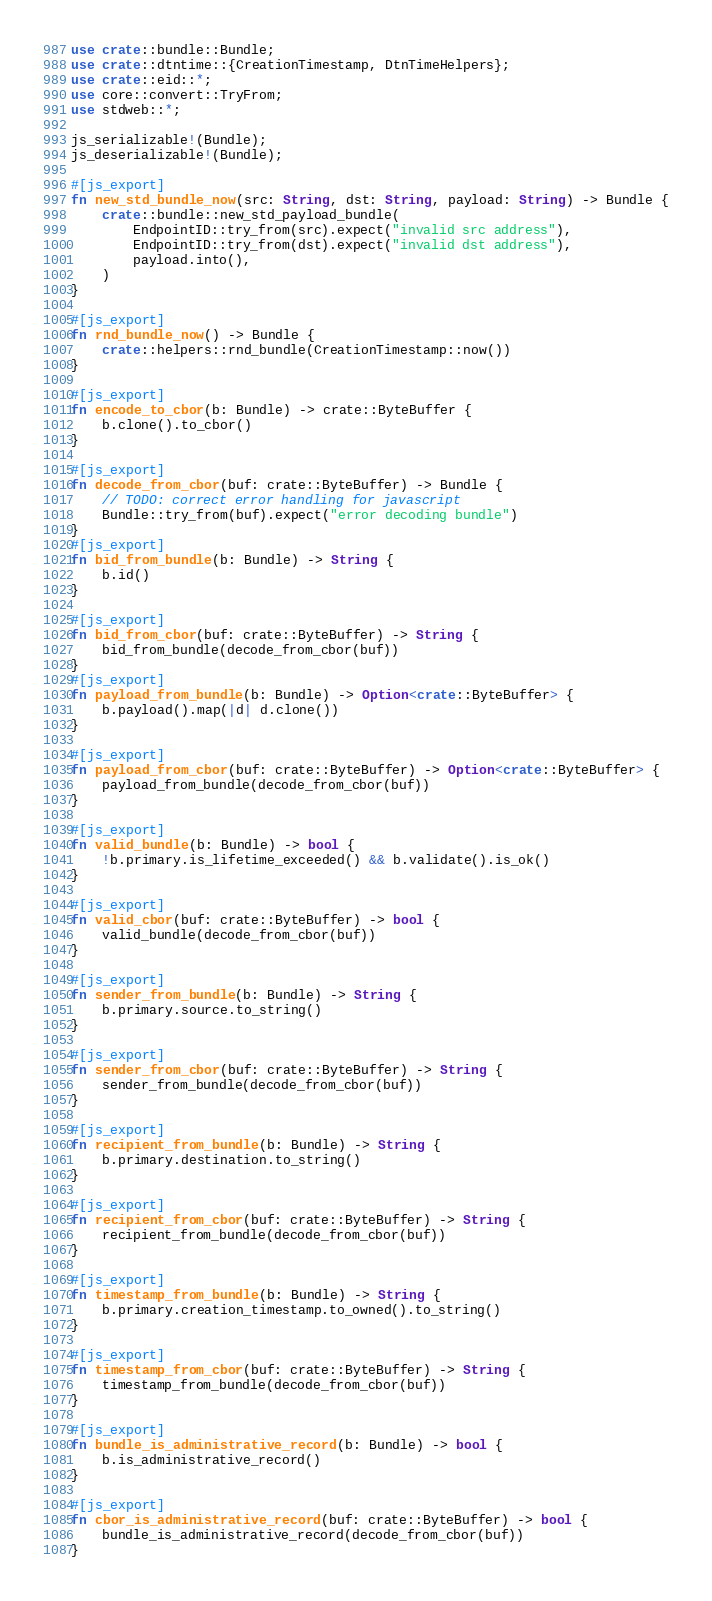<code> <loc_0><loc_0><loc_500><loc_500><_Rust_>use crate::bundle::Bundle;
use crate::dtntime::{CreationTimestamp, DtnTimeHelpers};
use crate::eid::*;
use core::convert::TryFrom;
use stdweb::*;

js_serializable!(Bundle);
js_deserializable!(Bundle);

#[js_export]
fn new_std_bundle_now(src: String, dst: String, payload: String) -> Bundle {
    crate::bundle::new_std_payload_bundle(
        EndpointID::try_from(src).expect("invalid src address"),
        EndpointID::try_from(dst).expect("invalid dst address"),
        payload.into(),
    )
}

#[js_export]
fn rnd_bundle_now() -> Bundle {
    crate::helpers::rnd_bundle(CreationTimestamp::now())
}

#[js_export]
fn encode_to_cbor(b: Bundle) -> crate::ByteBuffer {
    b.clone().to_cbor()
}

#[js_export]
fn decode_from_cbor(buf: crate::ByteBuffer) -> Bundle {
    // TODO: correct error handling for javascript
    Bundle::try_from(buf).expect("error decoding bundle")
}
#[js_export]
fn bid_from_bundle(b: Bundle) -> String {
    b.id()
}

#[js_export]
fn bid_from_cbor(buf: crate::ByteBuffer) -> String {
    bid_from_bundle(decode_from_cbor(buf))
}
#[js_export]
fn payload_from_bundle(b: Bundle) -> Option<crate::ByteBuffer> {
    b.payload().map(|d| d.clone())
}

#[js_export]
fn payload_from_cbor(buf: crate::ByteBuffer) -> Option<crate::ByteBuffer> {
    payload_from_bundle(decode_from_cbor(buf))
}

#[js_export]
fn valid_bundle(b: Bundle) -> bool {
    !b.primary.is_lifetime_exceeded() && b.validate().is_ok()
}

#[js_export]
fn valid_cbor(buf: crate::ByteBuffer) -> bool {
    valid_bundle(decode_from_cbor(buf))
}

#[js_export]
fn sender_from_bundle(b: Bundle) -> String {
    b.primary.source.to_string()
}

#[js_export]
fn sender_from_cbor(buf: crate::ByteBuffer) -> String {
    sender_from_bundle(decode_from_cbor(buf))
}

#[js_export]
fn recipient_from_bundle(b: Bundle) -> String {
    b.primary.destination.to_string()
}

#[js_export]
fn recipient_from_cbor(buf: crate::ByteBuffer) -> String {
    recipient_from_bundle(decode_from_cbor(buf))
}

#[js_export]
fn timestamp_from_bundle(b: Bundle) -> String {
    b.primary.creation_timestamp.to_owned().to_string()
}

#[js_export]
fn timestamp_from_cbor(buf: crate::ByteBuffer) -> String {
    timestamp_from_bundle(decode_from_cbor(buf))
}

#[js_export]
fn bundle_is_administrative_record(b: Bundle) -> bool {
    b.is_administrative_record()
}

#[js_export]
fn cbor_is_administrative_record(buf: crate::ByteBuffer) -> bool {
    bundle_is_administrative_record(decode_from_cbor(buf))
}
</code> 